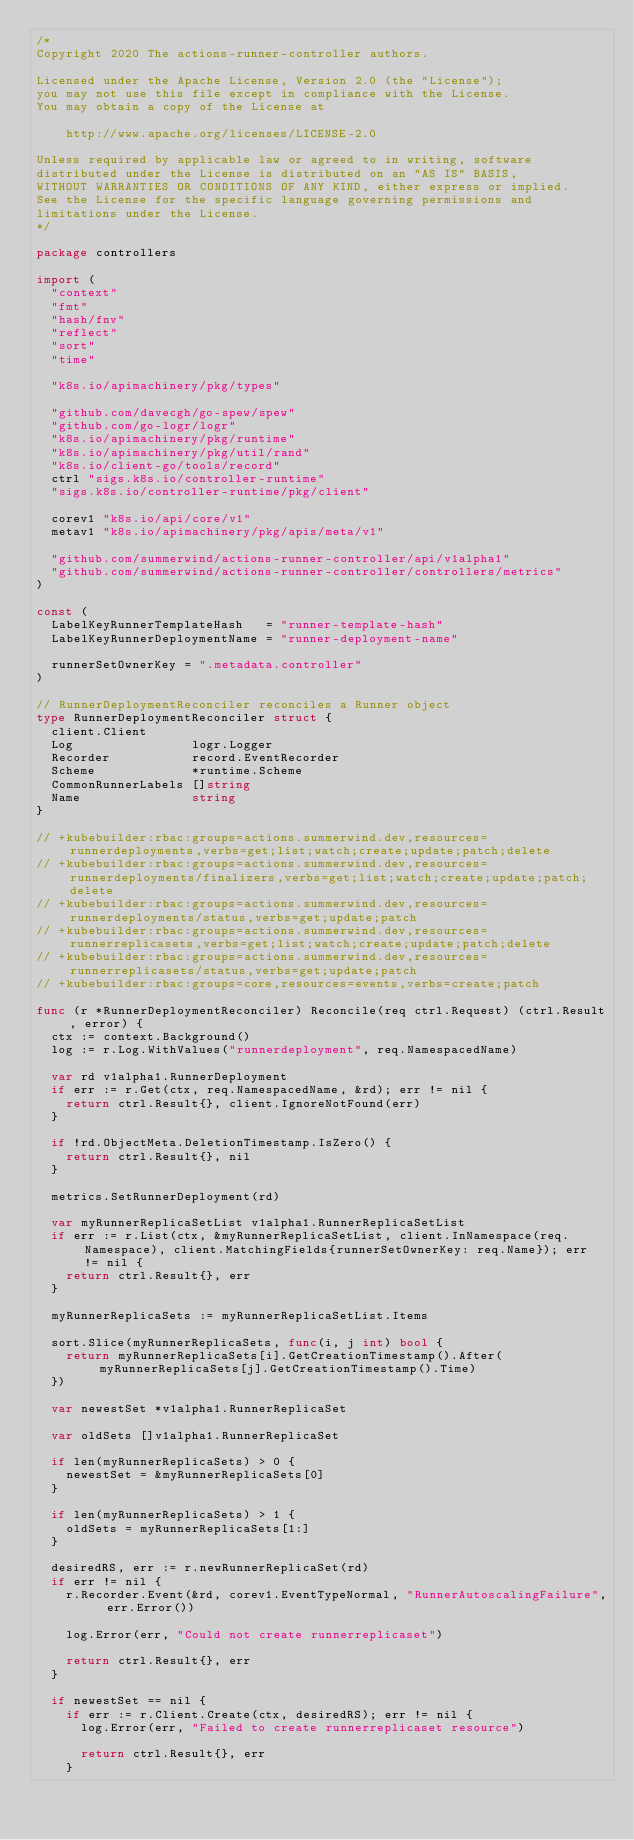Convert code to text. <code><loc_0><loc_0><loc_500><loc_500><_Go_>/*
Copyright 2020 The actions-runner-controller authors.

Licensed under the Apache License, Version 2.0 (the "License");
you may not use this file except in compliance with the License.
You may obtain a copy of the License at

    http://www.apache.org/licenses/LICENSE-2.0

Unless required by applicable law or agreed to in writing, software
distributed under the License is distributed on an "AS IS" BASIS,
WITHOUT WARRANTIES OR CONDITIONS OF ANY KIND, either express or implied.
See the License for the specific language governing permissions and
limitations under the License.
*/

package controllers

import (
	"context"
	"fmt"
	"hash/fnv"
	"reflect"
	"sort"
	"time"

	"k8s.io/apimachinery/pkg/types"

	"github.com/davecgh/go-spew/spew"
	"github.com/go-logr/logr"
	"k8s.io/apimachinery/pkg/runtime"
	"k8s.io/apimachinery/pkg/util/rand"
	"k8s.io/client-go/tools/record"
	ctrl "sigs.k8s.io/controller-runtime"
	"sigs.k8s.io/controller-runtime/pkg/client"

	corev1 "k8s.io/api/core/v1"
	metav1 "k8s.io/apimachinery/pkg/apis/meta/v1"

	"github.com/summerwind/actions-runner-controller/api/v1alpha1"
	"github.com/summerwind/actions-runner-controller/controllers/metrics"
)

const (
	LabelKeyRunnerTemplateHash   = "runner-template-hash"
	LabelKeyRunnerDeploymentName = "runner-deployment-name"

	runnerSetOwnerKey = ".metadata.controller"
)

// RunnerDeploymentReconciler reconciles a Runner object
type RunnerDeploymentReconciler struct {
	client.Client
	Log                logr.Logger
	Recorder           record.EventRecorder
	Scheme             *runtime.Scheme
	CommonRunnerLabels []string
	Name               string
}

// +kubebuilder:rbac:groups=actions.summerwind.dev,resources=runnerdeployments,verbs=get;list;watch;create;update;patch;delete
// +kubebuilder:rbac:groups=actions.summerwind.dev,resources=runnerdeployments/finalizers,verbs=get;list;watch;create;update;patch;delete
// +kubebuilder:rbac:groups=actions.summerwind.dev,resources=runnerdeployments/status,verbs=get;update;patch
// +kubebuilder:rbac:groups=actions.summerwind.dev,resources=runnerreplicasets,verbs=get;list;watch;create;update;patch;delete
// +kubebuilder:rbac:groups=actions.summerwind.dev,resources=runnerreplicasets/status,verbs=get;update;patch
// +kubebuilder:rbac:groups=core,resources=events,verbs=create;patch

func (r *RunnerDeploymentReconciler) Reconcile(req ctrl.Request) (ctrl.Result, error) {
	ctx := context.Background()
	log := r.Log.WithValues("runnerdeployment", req.NamespacedName)

	var rd v1alpha1.RunnerDeployment
	if err := r.Get(ctx, req.NamespacedName, &rd); err != nil {
		return ctrl.Result{}, client.IgnoreNotFound(err)
	}

	if !rd.ObjectMeta.DeletionTimestamp.IsZero() {
		return ctrl.Result{}, nil
	}

	metrics.SetRunnerDeployment(rd)

	var myRunnerReplicaSetList v1alpha1.RunnerReplicaSetList
	if err := r.List(ctx, &myRunnerReplicaSetList, client.InNamespace(req.Namespace), client.MatchingFields{runnerSetOwnerKey: req.Name}); err != nil {
		return ctrl.Result{}, err
	}

	myRunnerReplicaSets := myRunnerReplicaSetList.Items

	sort.Slice(myRunnerReplicaSets, func(i, j int) bool {
		return myRunnerReplicaSets[i].GetCreationTimestamp().After(myRunnerReplicaSets[j].GetCreationTimestamp().Time)
	})

	var newestSet *v1alpha1.RunnerReplicaSet

	var oldSets []v1alpha1.RunnerReplicaSet

	if len(myRunnerReplicaSets) > 0 {
		newestSet = &myRunnerReplicaSets[0]
	}

	if len(myRunnerReplicaSets) > 1 {
		oldSets = myRunnerReplicaSets[1:]
	}

	desiredRS, err := r.newRunnerReplicaSet(rd)
	if err != nil {
		r.Recorder.Event(&rd, corev1.EventTypeNormal, "RunnerAutoscalingFailure", err.Error())

		log.Error(err, "Could not create runnerreplicaset")

		return ctrl.Result{}, err
	}

	if newestSet == nil {
		if err := r.Client.Create(ctx, desiredRS); err != nil {
			log.Error(err, "Failed to create runnerreplicaset resource")

			return ctrl.Result{}, err
		}
</code> 